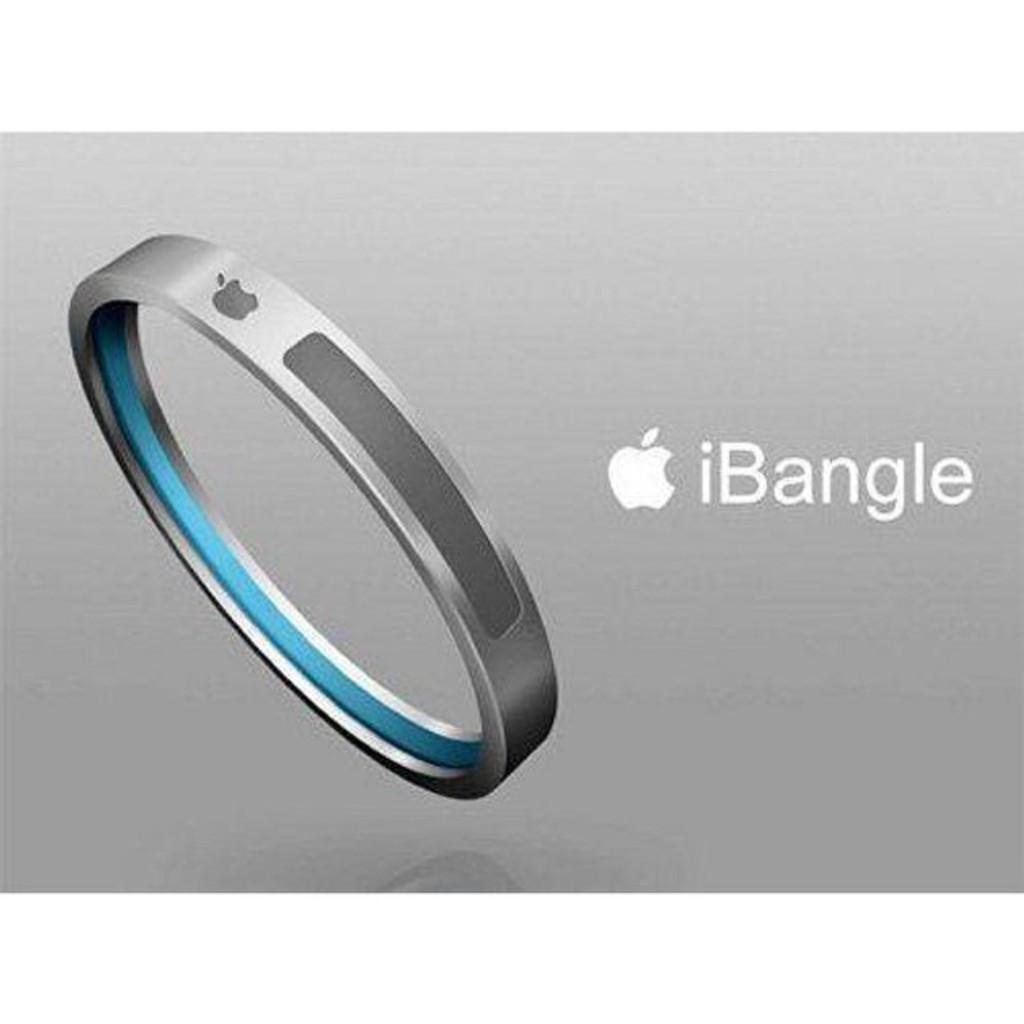<image>
Relay a brief, clear account of the picture shown. A picture of a new product from Apple called the iBangle. 